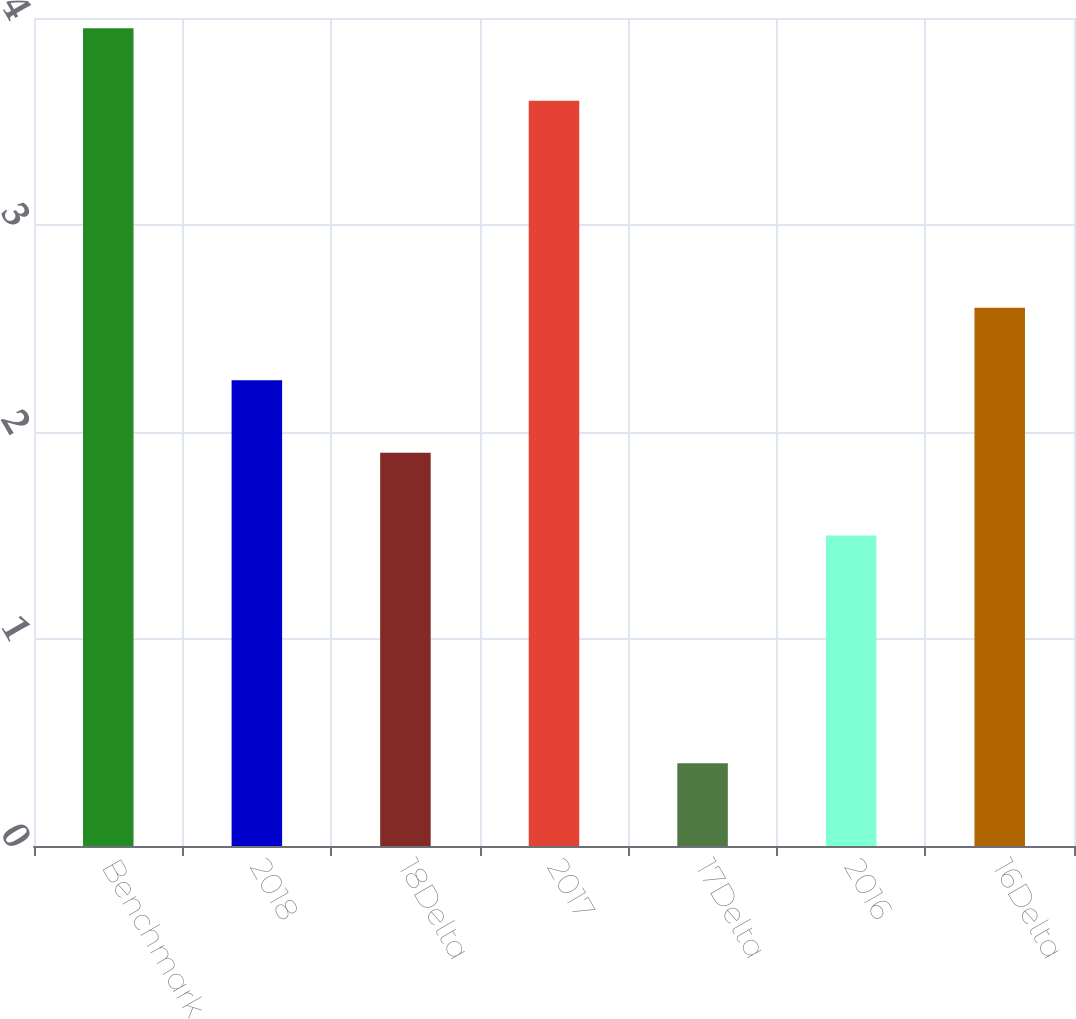Convert chart. <chart><loc_0><loc_0><loc_500><loc_500><bar_chart><fcel>Benchmark<fcel>2018<fcel>18Delta<fcel>2017<fcel>17Delta<fcel>2016<fcel>16Delta<nl><fcel>3.95<fcel>2.25<fcel>1.9<fcel>3.6<fcel>0.4<fcel>1.5<fcel>2.6<nl></chart> 